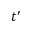Convert formula to latex. <formula><loc_0><loc_0><loc_500><loc_500>t ^ { \prime }</formula> 